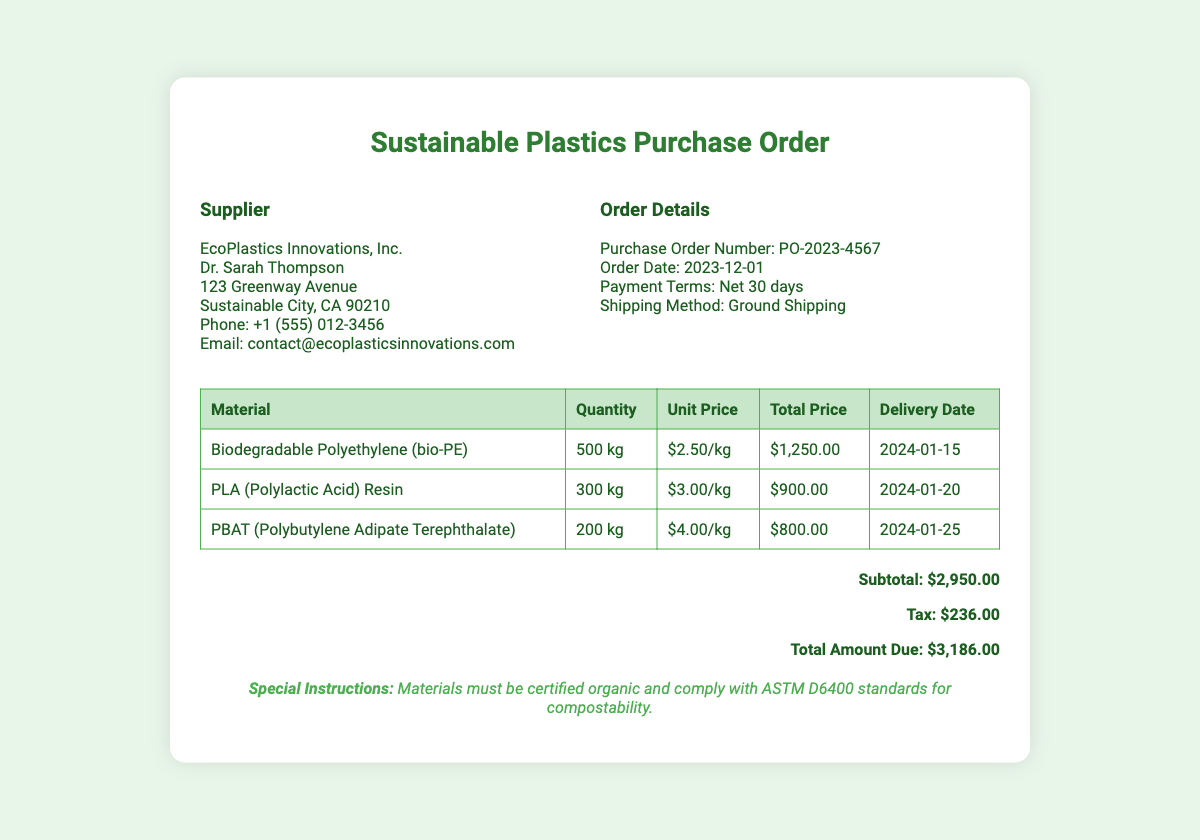What is the supplier's name? The supplier's name is mentioned in the document as EcoPlastics Innovations, Inc.
Answer: EcoPlastics Innovations, Inc What is the purchase order number? The purchase order number is provided in the order details section as PO-2023-4567.
Answer: PO-2023-4567 What is the total amount due? The total amount due is calculated in the total section of the document as $3,186.00.
Answer: $3,186.00 How many kilograms of PLA Resin are ordered? The quantity of PLA Resin ordered is listed in the table under Quantity as 300 kg.
Answer: 300 kg What is the delivery date for PBAT? The delivery date for PBAT is specified in the table under Delivery Date as 2024-01-25.
Answer: 2024-01-25 What is the payment term for this order? The payment term is indicated in the order details section as Net 30 days.
Answer: Net 30 days How much is the unit price for biodegradable polyethylene? The unit price for biodegradable polyethylene is shown in the table under Unit Price as $2.50/kg.
Answer: $2.50/kg What special instructions are noted in the document? Special instructions are provided at the bottom as materials must be certified organic and comply with ASTM D6400 standards.
Answer: Materials must be certified organic and comply with ASTM D6400 standards How much tax is included in the total amount? The tax amount is noted in the total section as $236.00.
Answer: $236.00 